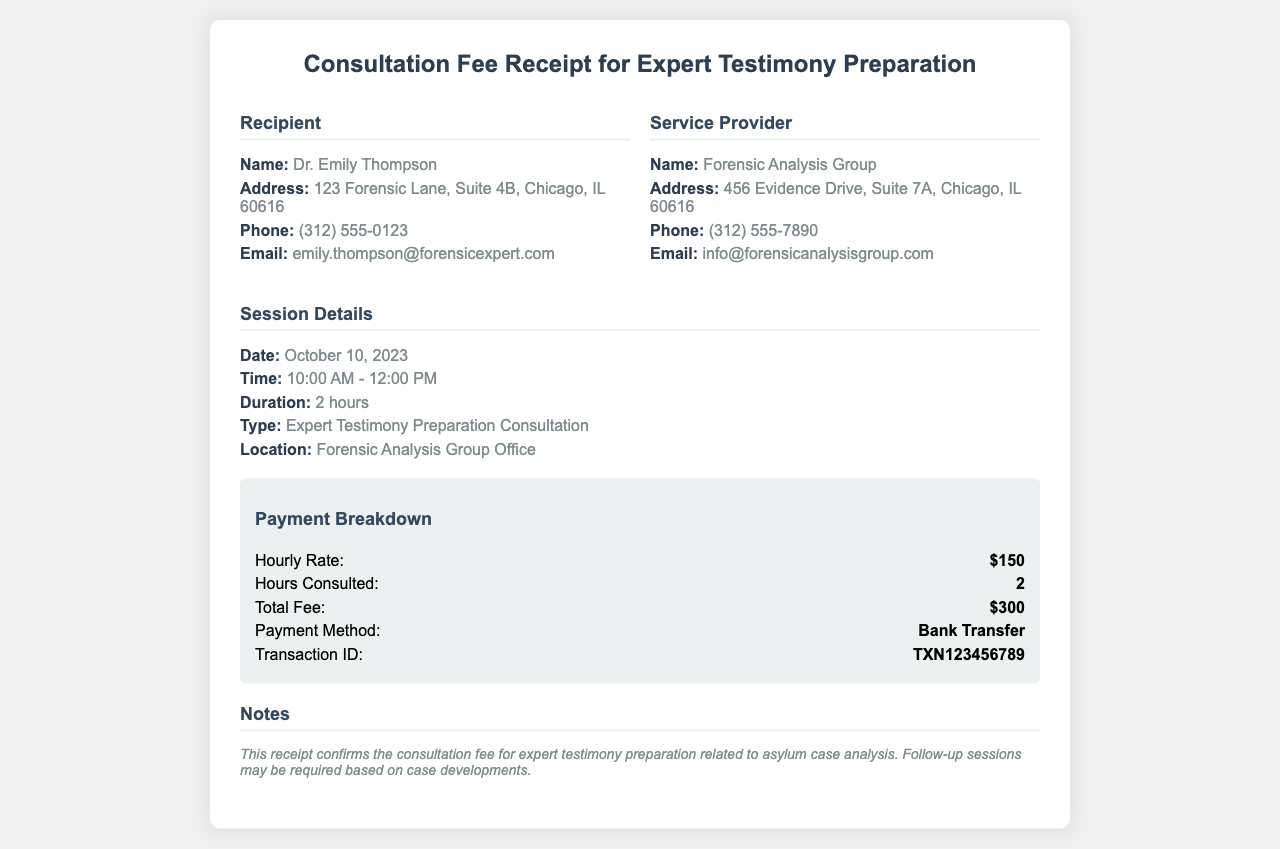What is the recipient's name? The recipient's name is provided in the document under the "Recipient" section, which states Dr. Emily Thompson.
Answer: Dr. Emily Thompson What is the total fee for the consultation? The total fee is found in the "Payment Breakdown" section, where it explicitly states the total fee as $300.
Answer: $300 What date was the consultation held? The date of the session can be found in the "Session Details" section, specifically listed as October 10, 2023.
Answer: October 10, 2023 What is the hourly rate charged for the consultation? The hourly rate is mentioned in the "Payment Breakdown" section and it is given as $150.
Answer: $150 What type of consultation was provided? The type of consultation is described in the "Session Details" section, where it is specified as Expert Testimony Preparation Consultation.
Answer: Expert Testimony Preparation Consultation What method of payment was used? The method of payment is listed under the "Payment Breakdown" section, described as Bank Transfer.
Answer: Bank Transfer How long did the consultation last? The duration of the consultation is summarized in the "Session Details" section, which indicates it lasted for 2 hours.
Answer: 2 hours What was the transaction ID for the payment? The transaction ID is found in the "Payment Breakdown" section, listed as TXN123456789.
Answer: TXN123456789 What is the email address of the recipient? The email address can be found in the "Recipient" section, stated as emily.thompson@forensicexpert.com.
Answer: emily.thompson@forensicexpert.com 